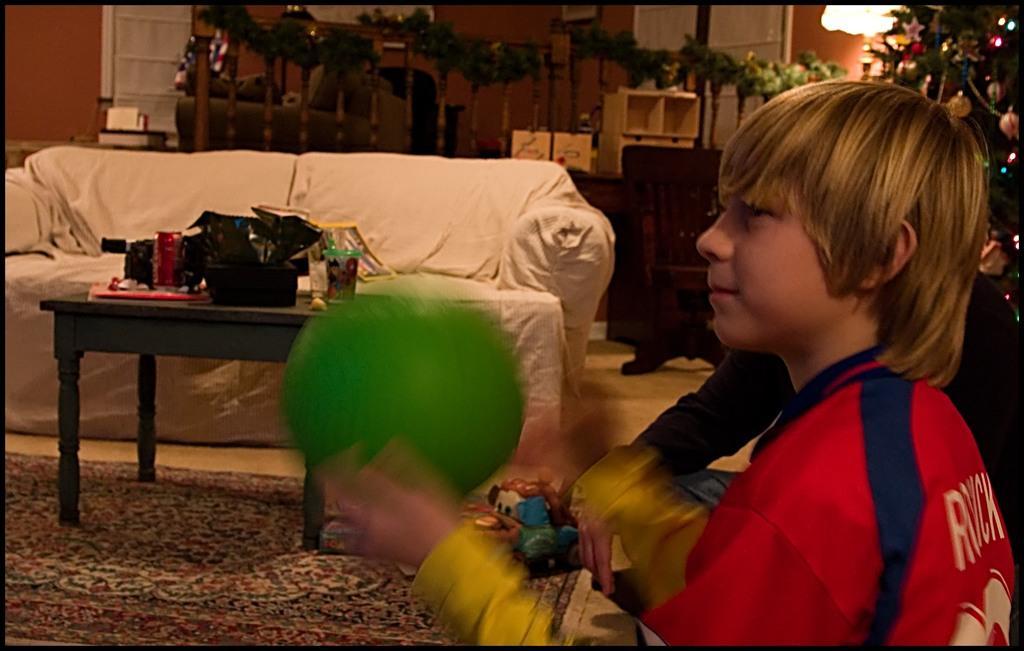Describe this image in one or two sentences. in this picture, In the right side there is a boy who is holding a ball which is in green color, In the middle there is a table which is in gray color and there is a sofa which is in white color and in the background there is a wall which is in orange color and there is a door of white color. 